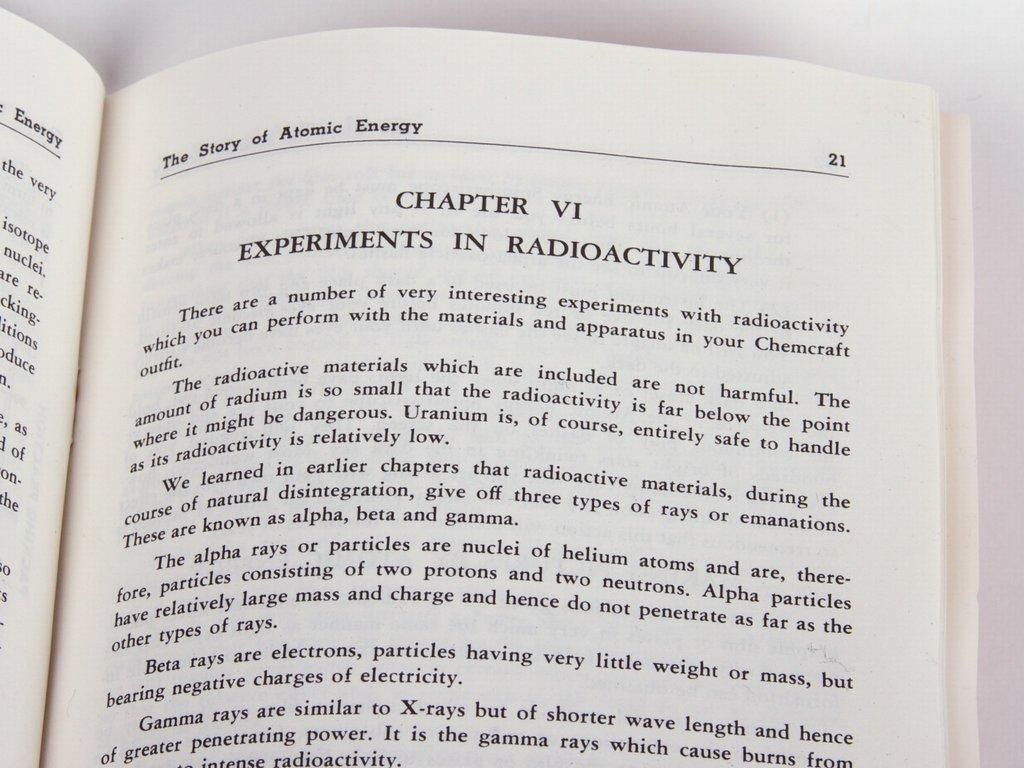<image>
Describe the image concisely. A chapter in a book called Experiments in Radioactivity 